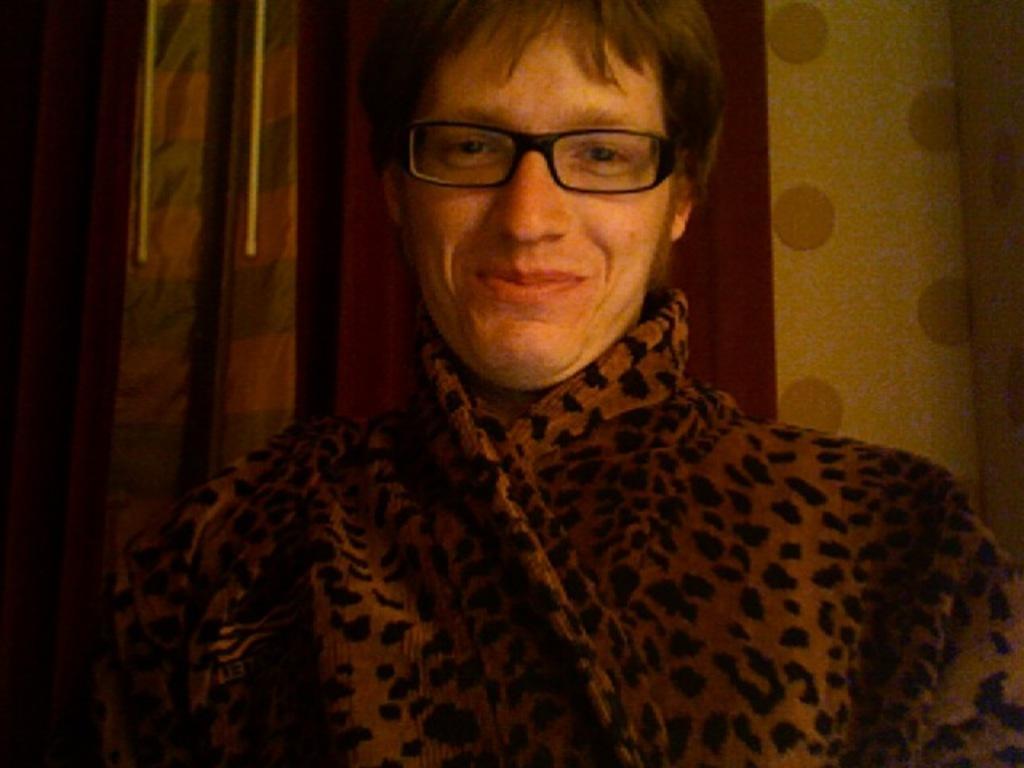Please provide a concise description of this image. In the foreground of the picture we can see a person wearing spectacles, behind him they might be curtains. 